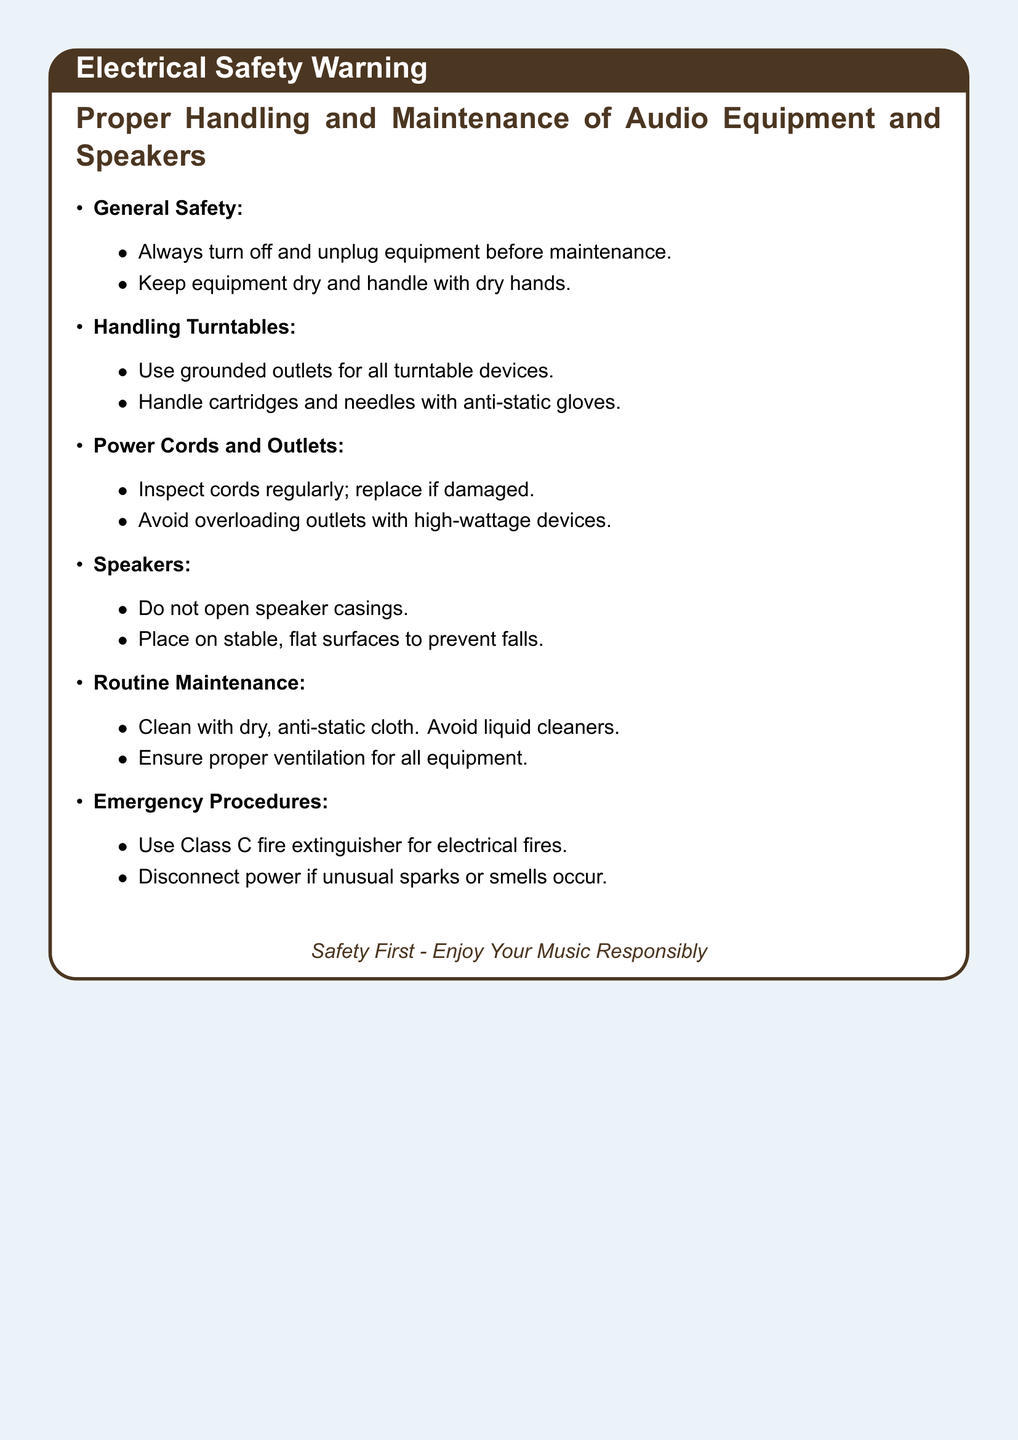What should you do before maintenance? The document states to always turn off and unplug equipment before maintenance.
Answer: turn off and unplug equipment What type of gloves should be used when handling cartridges? The document specifies to handle cartridges and needles with anti-static gloves.
Answer: anti-static gloves What fire extinguisher should be used for electrical fires? According to the document, a Class C fire extinguisher should be used for electrical fires.
Answer: Class C How should power cords be maintained? The document advises to inspect cords regularly and replace if damaged.
Answer: inspect regularly What surface should speakers be placed on? The document indicates that speakers should be placed on stable, flat surfaces to prevent falls.
Answer: stable, flat surfaces What should be avoided when cleaning equipment? The document mentions avoiding liquid cleaners when cleaning the equipment.
Answer: liquid cleaners What is the color of the document's background? The document's background color is vinyl blue, as indicated in the code.
Answer: vinyl blue What should you do if you notice unusual sparks or smells? The document advises to disconnect power if unusual sparks or smells occur.
Answer: disconnect power 